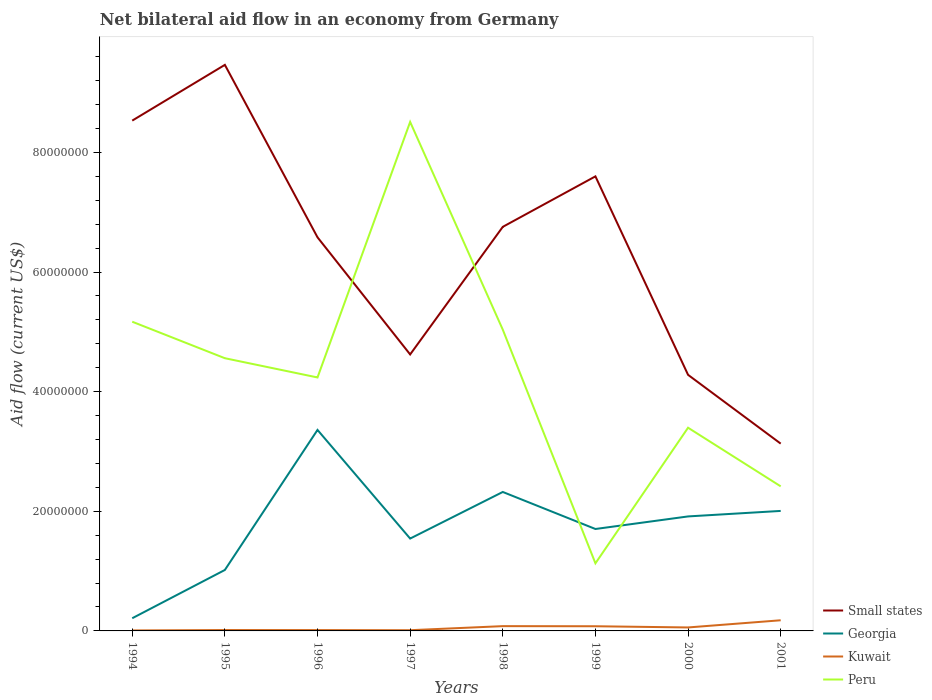Does the line corresponding to Peru intersect with the line corresponding to Kuwait?
Ensure brevity in your answer.  No. Is the number of lines equal to the number of legend labels?
Your response must be concise. Yes. Across all years, what is the maximum net bilateral aid flow in Kuwait?
Offer a terse response. 8.00e+04. In which year was the net bilateral aid flow in Small states maximum?
Ensure brevity in your answer.  2001. What is the total net bilateral aid flow in Georgia in the graph?
Make the answer very short. 3.17e+06. What is the difference between the highest and the second highest net bilateral aid flow in Georgia?
Your answer should be very brief. 3.15e+07. What is the difference between the highest and the lowest net bilateral aid flow in Georgia?
Offer a terse response. 4. Is the net bilateral aid flow in Georgia strictly greater than the net bilateral aid flow in Peru over the years?
Offer a terse response. No. Does the graph contain any zero values?
Offer a very short reply. No. Does the graph contain grids?
Ensure brevity in your answer.  No. Where does the legend appear in the graph?
Offer a very short reply. Bottom right. How many legend labels are there?
Give a very brief answer. 4. What is the title of the graph?
Your answer should be very brief. Net bilateral aid flow in an economy from Germany. What is the label or title of the Y-axis?
Give a very brief answer. Aid flow (current US$). What is the Aid flow (current US$) of Small states in 1994?
Provide a short and direct response. 8.53e+07. What is the Aid flow (current US$) in Georgia in 1994?
Make the answer very short. 2.12e+06. What is the Aid flow (current US$) in Peru in 1994?
Your answer should be very brief. 5.17e+07. What is the Aid flow (current US$) in Small states in 1995?
Make the answer very short. 9.46e+07. What is the Aid flow (current US$) in Georgia in 1995?
Keep it short and to the point. 1.02e+07. What is the Aid flow (current US$) of Peru in 1995?
Your answer should be very brief. 4.56e+07. What is the Aid flow (current US$) of Small states in 1996?
Offer a very short reply. 6.58e+07. What is the Aid flow (current US$) of Georgia in 1996?
Provide a succinct answer. 3.36e+07. What is the Aid flow (current US$) of Peru in 1996?
Offer a very short reply. 4.24e+07. What is the Aid flow (current US$) of Small states in 1997?
Offer a terse response. 4.62e+07. What is the Aid flow (current US$) in Georgia in 1997?
Ensure brevity in your answer.  1.54e+07. What is the Aid flow (current US$) in Peru in 1997?
Provide a succinct answer. 8.51e+07. What is the Aid flow (current US$) in Small states in 1998?
Provide a succinct answer. 6.76e+07. What is the Aid flow (current US$) of Georgia in 1998?
Your response must be concise. 2.32e+07. What is the Aid flow (current US$) of Peru in 1998?
Provide a succinct answer. 5.04e+07. What is the Aid flow (current US$) in Small states in 1999?
Ensure brevity in your answer.  7.60e+07. What is the Aid flow (current US$) of Georgia in 1999?
Offer a terse response. 1.70e+07. What is the Aid flow (current US$) of Kuwait in 1999?
Provide a succinct answer. 7.80e+05. What is the Aid flow (current US$) in Peru in 1999?
Your response must be concise. 1.13e+07. What is the Aid flow (current US$) of Small states in 2000?
Provide a succinct answer. 4.28e+07. What is the Aid flow (current US$) in Georgia in 2000?
Your response must be concise. 1.91e+07. What is the Aid flow (current US$) of Kuwait in 2000?
Your answer should be compact. 5.80e+05. What is the Aid flow (current US$) in Peru in 2000?
Provide a succinct answer. 3.40e+07. What is the Aid flow (current US$) of Small states in 2001?
Offer a very short reply. 3.13e+07. What is the Aid flow (current US$) in Georgia in 2001?
Offer a terse response. 2.01e+07. What is the Aid flow (current US$) of Kuwait in 2001?
Your response must be concise. 1.78e+06. What is the Aid flow (current US$) in Peru in 2001?
Make the answer very short. 2.42e+07. Across all years, what is the maximum Aid flow (current US$) in Small states?
Offer a very short reply. 9.46e+07. Across all years, what is the maximum Aid flow (current US$) of Georgia?
Offer a terse response. 3.36e+07. Across all years, what is the maximum Aid flow (current US$) in Kuwait?
Provide a short and direct response. 1.78e+06. Across all years, what is the maximum Aid flow (current US$) in Peru?
Your answer should be compact. 8.51e+07. Across all years, what is the minimum Aid flow (current US$) of Small states?
Ensure brevity in your answer.  3.13e+07. Across all years, what is the minimum Aid flow (current US$) in Georgia?
Give a very brief answer. 2.12e+06. Across all years, what is the minimum Aid flow (current US$) in Peru?
Your answer should be very brief. 1.13e+07. What is the total Aid flow (current US$) in Small states in the graph?
Make the answer very short. 5.10e+08. What is the total Aid flow (current US$) of Georgia in the graph?
Ensure brevity in your answer.  1.41e+08. What is the total Aid flow (current US$) in Kuwait in the graph?
Your answer should be compact. 4.43e+06. What is the total Aid flow (current US$) in Peru in the graph?
Your answer should be compact. 3.45e+08. What is the difference between the Aid flow (current US$) of Small states in 1994 and that in 1995?
Offer a terse response. -9.32e+06. What is the difference between the Aid flow (current US$) of Georgia in 1994 and that in 1995?
Give a very brief answer. -8.07e+06. What is the difference between the Aid flow (current US$) in Kuwait in 1994 and that in 1995?
Keep it short and to the point. -7.00e+04. What is the difference between the Aid flow (current US$) in Peru in 1994 and that in 1995?
Give a very brief answer. 6.10e+06. What is the difference between the Aid flow (current US$) in Small states in 1994 and that in 1996?
Offer a very short reply. 1.95e+07. What is the difference between the Aid flow (current US$) in Georgia in 1994 and that in 1996?
Provide a short and direct response. -3.15e+07. What is the difference between the Aid flow (current US$) in Peru in 1994 and that in 1996?
Provide a short and direct response. 9.32e+06. What is the difference between the Aid flow (current US$) of Small states in 1994 and that in 1997?
Offer a terse response. 3.91e+07. What is the difference between the Aid flow (current US$) of Georgia in 1994 and that in 1997?
Your response must be concise. -1.33e+07. What is the difference between the Aid flow (current US$) of Kuwait in 1994 and that in 1997?
Make the answer very short. -4.00e+04. What is the difference between the Aid flow (current US$) of Peru in 1994 and that in 1997?
Offer a terse response. -3.34e+07. What is the difference between the Aid flow (current US$) of Small states in 1994 and that in 1998?
Make the answer very short. 1.78e+07. What is the difference between the Aid flow (current US$) of Georgia in 1994 and that in 1998?
Your answer should be compact. -2.11e+07. What is the difference between the Aid flow (current US$) in Kuwait in 1994 and that in 1998?
Offer a very short reply. -7.20e+05. What is the difference between the Aid flow (current US$) of Peru in 1994 and that in 1998?
Offer a terse response. 1.33e+06. What is the difference between the Aid flow (current US$) in Small states in 1994 and that in 1999?
Your answer should be very brief. 9.32e+06. What is the difference between the Aid flow (current US$) in Georgia in 1994 and that in 1999?
Your response must be concise. -1.49e+07. What is the difference between the Aid flow (current US$) of Kuwait in 1994 and that in 1999?
Offer a terse response. -7.00e+05. What is the difference between the Aid flow (current US$) in Peru in 1994 and that in 1999?
Offer a terse response. 4.04e+07. What is the difference between the Aid flow (current US$) in Small states in 1994 and that in 2000?
Keep it short and to the point. 4.25e+07. What is the difference between the Aid flow (current US$) of Georgia in 1994 and that in 2000?
Offer a terse response. -1.70e+07. What is the difference between the Aid flow (current US$) in Kuwait in 1994 and that in 2000?
Make the answer very short. -5.00e+05. What is the difference between the Aid flow (current US$) of Peru in 1994 and that in 2000?
Provide a short and direct response. 1.77e+07. What is the difference between the Aid flow (current US$) of Small states in 1994 and that in 2001?
Provide a short and direct response. 5.40e+07. What is the difference between the Aid flow (current US$) of Georgia in 1994 and that in 2001?
Give a very brief answer. -1.79e+07. What is the difference between the Aid flow (current US$) of Kuwait in 1994 and that in 2001?
Ensure brevity in your answer.  -1.70e+06. What is the difference between the Aid flow (current US$) of Peru in 1994 and that in 2001?
Give a very brief answer. 2.75e+07. What is the difference between the Aid flow (current US$) in Small states in 1995 and that in 1996?
Offer a terse response. 2.88e+07. What is the difference between the Aid flow (current US$) in Georgia in 1995 and that in 1996?
Offer a very short reply. -2.34e+07. What is the difference between the Aid flow (current US$) of Kuwait in 1995 and that in 1996?
Make the answer very short. 10000. What is the difference between the Aid flow (current US$) in Peru in 1995 and that in 1996?
Your answer should be compact. 3.22e+06. What is the difference between the Aid flow (current US$) of Small states in 1995 and that in 1997?
Keep it short and to the point. 4.84e+07. What is the difference between the Aid flow (current US$) in Georgia in 1995 and that in 1997?
Your answer should be very brief. -5.25e+06. What is the difference between the Aid flow (current US$) in Peru in 1995 and that in 1997?
Offer a very short reply. -3.95e+07. What is the difference between the Aid flow (current US$) in Small states in 1995 and that in 1998?
Make the answer very short. 2.71e+07. What is the difference between the Aid flow (current US$) of Georgia in 1995 and that in 1998?
Provide a short and direct response. -1.30e+07. What is the difference between the Aid flow (current US$) of Kuwait in 1995 and that in 1998?
Offer a very short reply. -6.50e+05. What is the difference between the Aid flow (current US$) in Peru in 1995 and that in 1998?
Your response must be concise. -4.77e+06. What is the difference between the Aid flow (current US$) of Small states in 1995 and that in 1999?
Make the answer very short. 1.86e+07. What is the difference between the Aid flow (current US$) in Georgia in 1995 and that in 1999?
Provide a short and direct response. -6.85e+06. What is the difference between the Aid flow (current US$) in Kuwait in 1995 and that in 1999?
Offer a terse response. -6.30e+05. What is the difference between the Aid flow (current US$) in Peru in 1995 and that in 1999?
Your response must be concise. 3.43e+07. What is the difference between the Aid flow (current US$) of Small states in 1995 and that in 2000?
Give a very brief answer. 5.18e+07. What is the difference between the Aid flow (current US$) of Georgia in 1995 and that in 2000?
Keep it short and to the point. -8.95e+06. What is the difference between the Aid flow (current US$) of Kuwait in 1995 and that in 2000?
Give a very brief answer. -4.30e+05. What is the difference between the Aid flow (current US$) in Peru in 1995 and that in 2000?
Your response must be concise. 1.16e+07. What is the difference between the Aid flow (current US$) of Small states in 1995 and that in 2001?
Give a very brief answer. 6.33e+07. What is the difference between the Aid flow (current US$) of Georgia in 1995 and that in 2001?
Your answer should be compact. -9.87e+06. What is the difference between the Aid flow (current US$) in Kuwait in 1995 and that in 2001?
Offer a very short reply. -1.63e+06. What is the difference between the Aid flow (current US$) of Peru in 1995 and that in 2001?
Give a very brief answer. 2.14e+07. What is the difference between the Aid flow (current US$) of Small states in 1996 and that in 1997?
Keep it short and to the point. 1.96e+07. What is the difference between the Aid flow (current US$) in Georgia in 1996 and that in 1997?
Make the answer very short. 1.82e+07. What is the difference between the Aid flow (current US$) of Kuwait in 1996 and that in 1997?
Offer a very short reply. 2.00e+04. What is the difference between the Aid flow (current US$) of Peru in 1996 and that in 1997?
Make the answer very short. -4.27e+07. What is the difference between the Aid flow (current US$) of Small states in 1996 and that in 1998?
Give a very brief answer. -1.75e+06. What is the difference between the Aid flow (current US$) of Georgia in 1996 and that in 1998?
Provide a short and direct response. 1.04e+07. What is the difference between the Aid flow (current US$) in Kuwait in 1996 and that in 1998?
Your answer should be very brief. -6.60e+05. What is the difference between the Aid flow (current US$) of Peru in 1996 and that in 1998?
Ensure brevity in your answer.  -7.99e+06. What is the difference between the Aid flow (current US$) in Small states in 1996 and that in 1999?
Provide a short and direct response. -1.02e+07. What is the difference between the Aid flow (current US$) of Georgia in 1996 and that in 1999?
Your answer should be very brief. 1.66e+07. What is the difference between the Aid flow (current US$) in Kuwait in 1996 and that in 1999?
Your answer should be compact. -6.40e+05. What is the difference between the Aid flow (current US$) of Peru in 1996 and that in 1999?
Your answer should be very brief. 3.11e+07. What is the difference between the Aid flow (current US$) of Small states in 1996 and that in 2000?
Offer a terse response. 2.30e+07. What is the difference between the Aid flow (current US$) of Georgia in 1996 and that in 2000?
Provide a short and direct response. 1.45e+07. What is the difference between the Aid flow (current US$) of Kuwait in 1996 and that in 2000?
Keep it short and to the point. -4.40e+05. What is the difference between the Aid flow (current US$) in Peru in 1996 and that in 2000?
Offer a terse response. 8.40e+06. What is the difference between the Aid flow (current US$) of Small states in 1996 and that in 2001?
Provide a short and direct response. 3.45e+07. What is the difference between the Aid flow (current US$) in Georgia in 1996 and that in 2001?
Give a very brief answer. 1.35e+07. What is the difference between the Aid flow (current US$) of Kuwait in 1996 and that in 2001?
Make the answer very short. -1.64e+06. What is the difference between the Aid flow (current US$) of Peru in 1996 and that in 2001?
Provide a short and direct response. 1.82e+07. What is the difference between the Aid flow (current US$) in Small states in 1997 and that in 1998?
Make the answer very short. -2.13e+07. What is the difference between the Aid flow (current US$) of Georgia in 1997 and that in 1998?
Keep it short and to the point. -7.79e+06. What is the difference between the Aid flow (current US$) of Kuwait in 1997 and that in 1998?
Your answer should be very brief. -6.80e+05. What is the difference between the Aid flow (current US$) of Peru in 1997 and that in 1998?
Make the answer very short. 3.47e+07. What is the difference between the Aid flow (current US$) in Small states in 1997 and that in 1999?
Ensure brevity in your answer.  -2.98e+07. What is the difference between the Aid flow (current US$) in Georgia in 1997 and that in 1999?
Offer a very short reply. -1.60e+06. What is the difference between the Aid flow (current US$) in Kuwait in 1997 and that in 1999?
Your response must be concise. -6.60e+05. What is the difference between the Aid flow (current US$) in Peru in 1997 and that in 1999?
Your response must be concise. 7.38e+07. What is the difference between the Aid flow (current US$) of Small states in 1997 and that in 2000?
Your answer should be compact. 3.41e+06. What is the difference between the Aid flow (current US$) in Georgia in 1997 and that in 2000?
Your answer should be very brief. -3.70e+06. What is the difference between the Aid flow (current US$) of Kuwait in 1997 and that in 2000?
Your answer should be very brief. -4.60e+05. What is the difference between the Aid flow (current US$) of Peru in 1997 and that in 2000?
Keep it short and to the point. 5.11e+07. What is the difference between the Aid flow (current US$) of Small states in 1997 and that in 2001?
Ensure brevity in your answer.  1.49e+07. What is the difference between the Aid flow (current US$) of Georgia in 1997 and that in 2001?
Keep it short and to the point. -4.62e+06. What is the difference between the Aid flow (current US$) in Kuwait in 1997 and that in 2001?
Give a very brief answer. -1.66e+06. What is the difference between the Aid flow (current US$) in Peru in 1997 and that in 2001?
Make the answer very short. 6.09e+07. What is the difference between the Aid flow (current US$) in Small states in 1998 and that in 1999?
Your answer should be compact. -8.44e+06. What is the difference between the Aid flow (current US$) in Georgia in 1998 and that in 1999?
Provide a short and direct response. 6.19e+06. What is the difference between the Aid flow (current US$) in Peru in 1998 and that in 1999?
Offer a very short reply. 3.91e+07. What is the difference between the Aid flow (current US$) in Small states in 1998 and that in 2000?
Give a very brief answer. 2.47e+07. What is the difference between the Aid flow (current US$) in Georgia in 1998 and that in 2000?
Offer a very short reply. 4.09e+06. What is the difference between the Aid flow (current US$) in Kuwait in 1998 and that in 2000?
Ensure brevity in your answer.  2.20e+05. What is the difference between the Aid flow (current US$) of Peru in 1998 and that in 2000?
Keep it short and to the point. 1.64e+07. What is the difference between the Aid flow (current US$) of Small states in 1998 and that in 2001?
Offer a terse response. 3.62e+07. What is the difference between the Aid flow (current US$) in Georgia in 1998 and that in 2001?
Provide a short and direct response. 3.17e+06. What is the difference between the Aid flow (current US$) in Kuwait in 1998 and that in 2001?
Provide a succinct answer. -9.80e+05. What is the difference between the Aid flow (current US$) of Peru in 1998 and that in 2001?
Your answer should be very brief. 2.62e+07. What is the difference between the Aid flow (current US$) of Small states in 1999 and that in 2000?
Ensure brevity in your answer.  3.32e+07. What is the difference between the Aid flow (current US$) of Georgia in 1999 and that in 2000?
Give a very brief answer. -2.10e+06. What is the difference between the Aid flow (current US$) of Peru in 1999 and that in 2000?
Make the answer very short. -2.27e+07. What is the difference between the Aid flow (current US$) of Small states in 1999 and that in 2001?
Your response must be concise. 4.47e+07. What is the difference between the Aid flow (current US$) in Georgia in 1999 and that in 2001?
Offer a very short reply. -3.02e+06. What is the difference between the Aid flow (current US$) in Kuwait in 1999 and that in 2001?
Provide a succinct answer. -1.00e+06. What is the difference between the Aid flow (current US$) of Peru in 1999 and that in 2001?
Keep it short and to the point. -1.29e+07. What is the difference between the Aid flow (current US$) in Small states in 2000 and that in 2001?
Keep it short and to the point. 1.15e+07. What is the difference between the Aid flow (current US$) in Georgia in 2000 and that in 2001?
Make the answer very short. -9.20e+05. What is the difference between the Aid flow (current US$) of Kuwait in 2000 and that in 2001?
Your answer should be very brief. -1.20e+06. What is the difference between the Aid flow (current US$) in Peru in 2000 and that in 2001?
Your answer should be very brief. 9.80e+06. What is the difference between the Aid flow (current US$) in Small states in 1994 and the Aid flow (current US$) in Georgia in 1995?
Your answer should be very brief. 7.51e+07. What is the difference between the Aid flow (current US$) in Small states in 1994 and the Aid flow (current US$) in Kuwait in 1995?
Your response must be concise. 8.52e+07. What is the difference between the Aid flow (current US$) of Small states in 1994 and the Aid flow (current US$) of Peru in 1995?
Provide a short and direct response. 3.97e+07. What is the difference between the Aid flow (current US$) of Georgia in 1994 and the Aid flow (current US$) of Kuwait in 1995?
Offer a terse response. 1.97e+06. What is the difference between the Aid flow (current US$) of Georgia in 1994 and the Aid flow (current US$) of Peru in 1995?
Give a very brief answer. -4.35e+07. What is the difference between the Aid flow (current US$) in Kuwait in 1994 and the Aid flow (current US$) in Peru in 1995?
Your answer should be compact. -4.55e+07. What is the difference between the Aid flow (current US$) in Small states in 1994 and the Aid flow (current US$) in Georgia in 1996?
Provide a succinct answer. 5.17e+07. What is the difference between the Aid flow (current US$) of Small states in 1994 and the Aid flow (current US$) of Kuwait in 1996?
Make the answer very short. 8.52e+07. What is the difference between the Aid flow (current US$) in Small states in 1994 and the Aid flow (current US$) in Peru in 1996?
Ensure brevity in your answer.  4.29e+07. What is the difference between the Aid flow (current US$) of Georgia in 1994 and the Aid flow (current US$) of Kuwait in 1996?
Offer a terse response. 1.98e+06. What is the difference between the Aid flow (current US$) in Georgia in 1994 and the Aid flow (current US$) in Peru in 1996?
Provide a short and direct response. -4.02e+07. What is the difference between the Aid flow (current US$) of Kuwait in 1994 and the Aid flow (current US$) of Peru in 1996?
Your answer should be very brief. -4.23e+07. What is the difference between the Aid flow (current US$) of Small states in 1994 and the Aid flow (current US$) of Georgia in 1997?
Offer a very short reply. 6.99e+07. What is the difference between the Aid flow (current US$) in Small states in 1994 and the Aid flow (current US$) in Kuwait in 1997?
Offer a very short reply. 8.52e+07. What is the difference between the Aid flow (current US$) of Georgia in 1994 and the Aid flow (current US$) of Peru in 1997?
Your answer should be compact. -8.30e+07. What is the difference between the Aid flow (current US$) in Kuwait in 1994 and the Aid flow (current US$) in Peru in 1997?
Keep it short and to the point. -8.50e+07. What is the difference between the Aid flow (current US$) of Small states in 1994 and the Aid flow (current US$) of Georgia in 1998?
Your answer should be very brief. 6.21e+07. What is the difference between the Aid flow (current US$) of Small states in 1994 and the Aid flow (current US$) of Kuwait in 1998?
Offer a terse response. 8.45e+07. What is the difference between the Aid flow (current US$) of Small states in 1994 and the Aid flow (current US$) of Peru in 1998?
Your response must be concise. 3.50e+07. What is the difference between the Aid flow (current US$) in Georgia in 1994 and the Aid flow (current US$) in Kuwait in 1998?
Your response must be concise. 1.32e+06. What is the difference between the Aid flow (current US$) in Georgia in 1994 and the Aid flow (current US$) in Peru in 1998?
Your answer should be very brief. -4.82e+07. What is the difference between the Aid flow (current US$) in Kuwait in 1994 and the Aid flow (current US$) in Peru in 1998?
Offer a terse response. -5.03e+07. What is the difference between the Aid flow (current US$) of Small states in 1994 and the Aid flow (current US$) of Georgia in 1999?
Make the answer very short. 6.83e+07. What is the difference between the Aid flow (current US$) of Small states in 1994 and the Aid flow (current US$) of Kuwait in 1999?
Your answer should be compact. 8.45e+07. What is the difference between the Aid flow (current US$) in Small states in 1994 and the Aid flow (current US$) in Peru in 1999?
Make the answer very short. 7.40e+07. What is the difference between the Aid flow (current US$) of Georgia in 1994 and the Aid flow (current US$) of Kuwait in 1999?
Make the answer very short. 1.34e+06. What is the difference between the Aid flow (current US$) of Georgia in 1994 and the Aid flow (current US$) of Peru in 1999?
Keep it short and to the point. -9.18e+06. What is the difference between the Aid flow (current US$) of Kuwait in 1994 and the Aid flow (current US$) of Peru in 1999?
Your answer should be compact. -1.12e+07. What is the difference between the Aid flow (current US$) of Small states in 1994 and the Aid flow (current US$) of Georgia in 2000?
Offer a very short reply. 6.62e+07. What is the difference between the Aid flow (current US$) of Small states in 1994 and the Aid flow (current US$) of Kuwait in 2000?
Give a very brief answer. 8.47e+07. What is the difference between the Aid flow (current US$) in Small states in 1994 and the Aid flow (current US$) in Peru in 2000?
Keep it short and to the point. 5.13e+07. What is the difference between the Aid flow (current US$) of Georgia in 1994 and the Aid flow (current US$) of Kuwait in 2000?
Keep it short and to the point. 1.54e+06. What is the difference between the Aid flow (current US$) of Georgia in 1994 and the Aid flow (current US$) of Peru in 2000?
Provide a succinct answer. -3.18e+07. What is the difference between the Aid flow (current US$) of Kuwait in 1994 and the Aid flow (current US$) of Peru in 2000?
Your response must be concise. -3.39e+07. What is the difference between the Aid flow (current US$) in Small states in 1994 and the Aid flow (current US$) in Georgia in 2001?
Ensure brevity in your answer.  6.52e+07. What is the difference between the Aid flow (current US$) of Small states in 1994 and the Aid flow (current US$) of Kuwait in 2001?
Keep it short and to the point. 8.35e+07. What is the difference between the Aid flow (current US$) of Small states in 1994 and the Aid flow (current US$) of Peru in 2001?
Your answer should be compact. 6.11e+07. What is the difference between the Aid flow (current US$) in Georgia in 1994 and the Aid flow (current US$) in Peru in 2001?
Offer a very short reply. -2.20e+07. What is the difference between the Aid flow (current US$) in Kuwait in 1994 and the Aid flow (current US$) in Peru in 2001?
Your answer should be compact. -2.41e+07. What is the difference between the Aid flow (current US$) of Small states in 1995 and the Aid flow (current US$) of Georgia in 1996?
Keep it short and to the point. 6.10e+07. What is the difference between the Aid flow (current US$) of Small states in 1995 and the Aid flow (current US$) of Kuwait in 1996?
Provide a succinct answer. 9.45e+07. What is the difference between the Aid flow (current US$) in Small states in 1995 and the Aid flow (current US$) in Peru in 1996?
Offer a very short reply. 5.23e+07. What is the difference between the Aid flow (current US$) of Georgia in 1995 and the Aid flow (current US$) of Kuwait in 1996?
Offer a very short reply. 1.00e+07. What is the difference between the Aid flow (current US$) in Georgia in 1995 and the Aid flow (current US$) in Peru in 1996?
Ensure brevity in your answer.  -3.22e+07. What is the difference between the Aid flow (current US$) of Kuwait in 1995 and the Aid flow (current US$) of Peru in 1996?
Keep it short and to the point. -4.22e+07. What is the difference between the Aid flow (current US$) of Small states in 1995 and the Aid flow (current US$) of Georgia in 1997?
Offer a very short reply. 7.92e+07. What is the difference between the Aid flow (current US$) in Small states in 1995 and the Aid flow (current US$) in Kuwait in 1997?
Give a very brief answer. 9.45e+07. What is the difference between the Aid flow (current US$) of Small states in 1995 and the Aid flow (current US$) of Peru in 1997?
Your answer should be compact. 9.54e+06. What is the difference between the Aid flow (current US$) of Georgia in 1995 and the Aid flow (current US$) of Kuwait in 1997?
Keep it short and to the point. 1.01e+07. What is the difference between the Aid flow (current US$) in Georgia in 1995 and the Aid flow (current US$) in Peru in 1997?
Offer a terse response. -7.49e+07. What is the difference between the Aid flow (current US$) in Kuwait in 1995 and the Aid flow (current US$) in Peru in 1997?
Your answer should be compact. -8.49e+07. What is the difference between the Aid flow (current US$) in Small states in 1995 and the Aid flow (current US$) in Georgia in 1998?
Keep it short and to the point. 7.14e+07. What is the difference between the Aid flow (current US$) of Small states in 1995 and the Aid flow (current US$) of Kuwait in 1998?
Make the answer very short. 9.38e+07. What is the difference between the Aid flow (current US$) in Small states in 1995 and the Aid flow (current US$) in Peru in 1998?
Your response must be concise. 4.43e+07. What is the difference between the Aid flow (current US$) of Georgia in 1995 and the Aid flow (current US$) of Kuwait in 1998?
Ensure brevity in your answer.  9.39e+06. What is the difference between the Aid flow (current US$) of Georgia in 1995 and the Aid flow (current US$) of Peru in 1998?
Provide a succinct answer. -4.02e+07. What is the difference between the Aid flow (current US$) in Kuwait in 1995 and the Aid flow (current US$) in Peru in 1998?
Give a very brief answer. -5.02e+07. What is the difference between the Aid flow (current US$) in Small states in 1995 and the Aid flow (current US$) in Georgia in 1999?
Offer a very short reply. 7.76e+07. What is the difference between the Aid flow (current US$) of Small states in 1995 and the Aid flow (current US$) of Kuwait in 1999?
Make the answer very short. 9.38e+07. What is the difference between the Aid flow (current US$) in Small states in 1995 and the Aid flow (current US$) in Peru in 1999?
Provide a succinct answer. 8.33e+07. What is the difference between the Aid flow (current US$) in Georgia in 1995 and the Aid flow (current US$) in Kuwait in 1999?
Your response must be concise. 9.41e+06. What is the difference between the Aid flow (current US$) of Georgia in 1995 and the Aid flow (current US$) of Peru in 1999?
Make the answer very short. -1.11e+06. What is the difference between the Aid flow (current US$) of Kuwait in 1995 and the Aid flow (current US$) of Peru in 1999?
Make the answer very short. -1.12e+07. What is the difference between the Aid flow (current US$) of Small states in 1995 and the Aid flow (current US$) of Georgia in 2000?
Your answer should be compact. 7.55e+07. What is the difference between the Aid flow (current US$) in Small states in 1995 and the Aid flow (current US$) in Kuwait in 2000?
Your response must be concise. 9.40e+07. What is the difference between the Aid flow (current US$) in Small states in 1995 and the Aid flow (current US$) in Peru in 2000?
Your response must be concise. 6.07e+07. What is the difference between the Aid flow (current US$) of Georgia in 1995 and the Aid flow (current US$) of Kuwait in 2000?
Ensure brevity in your answer.  9.61e+06. What is the difference between the Aid flow (current US$) of Georgia in 1995 and the Aid flow (current US$) of Peru in 2000?
Ensure brevity in your answer.  -2.38e+07. What is the difference between the Aid flow (current US$) of Kuwait in 1995 and the Aid flow (current US$) of Peru in 2000?
Offer a terse response. -3.38e+07. What is the difference between the Aid flow (current US$) of Small states in 1995 and the Aid flow (current US$) of Georgia in 2001?
Ensure brevity in your answer.  7.46e+07. What is the difference between the Aid flow (current US$) of Small states in 1995 and the Aid flow (current US$) of Kuwait in 2001?
Offer a terse response. 9.28e+07. What is the difference between the Aid flow (current US$) in Small states in 1995 and the Aid flow (current US$) in Peru in 2001?
Keep it short and to the point. 7.05e+07. What is the difference between the Aid flow (current US$) of Georgia in 1995 and the Aid flow (current US$) of Kuwait in 2001?
Make the answer very short. 8.41e+06. What is the difference between the Aid flow (current US$) of Georgia in 1995 and the Aid flow (current US$) of Peru in 2001?
Provide a short and direct response. -1.40e+07. What is the difference between the Aid flow (current US$) of Kuwait in 1995 and the Aid flow (current US$) of Peru in 2001?
Your answer should be very brief. -2.40e+07. What is the difference between the Aid flow (current US$) in Small states in 1996 and the Aid flow (current US$) in Georgia in 1997?
Keep it short and to the point. 5.04e+07. What is the difference between the Aid flow (current US$) of Small states in 1996 and the Aid flow (current US$) of Kuwait in 1997?
Provide a short and direct response. 6.57e+07. What is the difference between the Aid flow (current US$) in Small states in 1996 and the Aid flow (current US$) in Peru in 1997?
Ensure brevity in your answer.  -1.93e+07. What is the difference between the Aid flow (current US$) in Georgia in 1996 and the Aid flow (current US$) in Kuwait in 1997?
Make the answer very short. 3.35e+07. What is the difference between the Aid flow (current US$) in Georgia in 1996 and the Aid flow (current US$) in Peru in 1997?
Provide a short and direct response. -5.15e+07. What is the difference between the Aid flow (current US$) of Kuwait in 1996 and the Aid flow (current US$) of Peru in 1997?
Your answer should be very brief. -8.50e+07. What is the difference between the Aid flow (current US$) in Small states in 1996 and the Aid flow (current US$) in Georgia in 1998?
Provide a succinct answer. 4.26e+07. What is the difference between the Aid flow (current US$) of Small states in 1996 and the Aid flow (current US$) of Kuwait in 1998?
Provide a succinct answer. 6.50e+07. What is the difference between the Aid flow (current US$) of Small states in 1996 and the Aid flow (current US$) of Peru in 1998?
Offer a very short reply. 1.54e+07. What is the difference between the Aid flow (current US$) of Georgia in 1996 and the Aid flow (current US$) of Kuwait in 1998?
Provide a short and direct response. 3.28e+07. What is the difference between the Aid flow (current US$) of Georgia in 1996 and the Aid flow (current US$) of Peru in 1998?
Provide a succinct answer. -1.68e+07. What is the difference between the Aid flow (current US$) of Kuwait in 1996 and the Aid flow (current US$) of Peru in 1998?
Ensure brevity in your answer.  -5.02e+07. What is the difference between the Aid flow (current US$) of Small states in 1996 and the Aid flow (current US$) of Georgia in 1999?
Offer a terse response. 4.88e+07. What is the difference between the Aid flow (current US$) in Small states in 1996 and the Aid flow (current US$) in Kuwait in 1999?
Ensure brevity in your answer.  6.50e+07. What is the difference between the Aid flow (current US$) in Small states in 1996 and the Aid flow (current US$) in Peru in 1999?
Offer a very short reply. 5.45e+07. What is the difference between the Aid flow (current US$) of Georgia in 1996 and the Aid flow (current US$) of Kuwait in 1999?
Your answer should be compact. 3.28e+07. What is the difference between the Aid flow (current US$) in Georgia in 1996 and the Aid flow (current US$) in Peru in 1999?
Make the answer very short. 2.23e+07. What is the difference between the Aid flow (current US$) of Kuwait in 1996 and the Aid flow (current US$) of Peru in 1999?
Provide a succinct answer. -1.12e+07. What is the difference between the Aid flow (current US$) in Small states in 1996 and the Aid flow (current US$) in Georgia in 2000?
Provide a succinct answer. 4.67e+07. What is the difference between the Aid flow (current US$) in Small states in 1996 and the Aid flow (current US$) in Kuwait in 2000?
Provide a succinct answer. 6.52e+07. What is the difference between the Aid flow (current US$) in Small states in 1996 and the Aid flow (current US$) in Peru in 2000?
Your answer should be very brief. 3.18e+07. What is the difference between the Aid flow (current US$) in Georgia in 1996 and the Aid flow (current US$) in Kuwait in 2000?
Your answer should be compact. 3.30e+07. What is the difference between the Aid flow (current US$) of Georgia in 1996 and the Aid flow (current US$) of Peru in 2000?
Give a very brief answer. -3.70e+05. What is the difference between the Aid flow (current US$) of Kuwait in 1996 and the Aid flow (current US$) of Peru in 2000?
Make the answer very short. -3.38e+07. What is the difference between the Aid flow (current US$) of Small states in 1996 and the Aid flow (current US$) of Georgia in 2001?
Your answer should be compact. 4.57e+07. What is the difference between the Aid flow (current US$) of Small states in 1996 and the Aid flow (current US$) of Kuwait in 2001?
Offer a terse response. 6.40e+07. What is the difference between the Aid flow (current US$) of Small states in 1996 and the Aid flow (current US$) of Peru in 2001?
Make the answer very short. 4.16e+07. What is the difference between the Aid flow (current US$) in Georgia in 1996 and the Aid flow (current US$) in Kuwait in 2001?
Keep it short and to the point. 3.18e+07. What is the difference between the Aid flow (current US$) in Georgia in 1996 and the Aid flow (current US$) in Peru in 2001?
Give a very brief answer. 9.43e+06. What is the difference between the Aid flow (current US$) of Kuwait in 1996 and the Aid flow (current US$) of Peru in 2001?
Provide a short and direct response. -2.40e+07. What is the difference between the Aid flow (current US$) of Small states in 1997 and the Aid flow (current US$) of Georgia in 1998?
Ensure brevity in your answer.  2.30e+07. What is the difference between the Aid flow (current US$) in Small states in 1997 and the Aid flow (current US$) in Kuwait in 1998?
Your answer should be very brief. 4.54e+07. What is the difference between the Aid flow (current US$) in Small states in 1997 and the Aid flow (current US$) in Peru in 1998?
Ensure brevity in your answer.  -4.14e+06. What is the difference between the Aid flow (current US$) of Georgia in 1997 and the Aid flow (current US$) of Kuwait in 1998?
Your answer should be very brief. 1.46e+07. What is the difference between the Aid flow (current US$) in Georgia in 1997 and the Aid flow (current US$) in Peru in 1998?
Make the answer very short. -3.49e+07. What is the difference between the Aid flow (current US$) of Kuwait in 1997 and the Aid flow (current US$) of Peru in 1998?
Offer a terse response. -5.02e+07. What is the difference between the Aid flow (current US$) of Small states in 1997 and the Aid flow (current US$) of Georgia in 1999?
Offer a very short reply. 2.92e+07. What is the difference between the Aid flow (current US$) in Small states in 1997 and the Aid flow (current US$) in Kuwait in 1999?
Your answer should be very brief. 4.54e+07. What is the difference between the Aid flow (current US$) in Small states in 1997 and the Aid flow (current US$) in Peru in 1999?
Your answer should be compact. 3.49e+07. What is the difference between the Aid flow (current US$) of Georgia in 1997 and the Aid flow (current US$) of Kuwait in 1999?
Make the answer very short. 1.47e+07. What is the difference between the Aid flow (current US$) of Georgia in 1997 and the Aid flow (current US$) of Peru in 1999?
Your answer should be very brief. 4.14e+06. What is the difference between the Aid flow (current US$) of Kuwait in 1997 and the Aid flow (current US$) of Peru in 1999?
Offer a very short reply. -1.12e+07. What is the difference between the Aid flow (current US$) of Small states in 1997 and the Aid flow (current US$) of Georgia in 2000?
Make the answer very short. 2.71e+07. What is the difference between the Aid flow (current US$) in Small states in 1997 and the Aid flow (current US$) in Kuwait in 2000?
Offer a terse response. 4.56e+07. What is the difference between the Aid flow (current US$) of Small states in 1997 and the Aid flow (current US$) of Peru in 2000?
Ensure brevity in your answer.  1.22e+07. What is the difference between the Aid flow (current US$) in Georgia in 1997 and the Aid flow (current US$) in Kuwait in 2000?
Provide a short and direct response. 1.49e+07. What is the difference between the Aid flow (current US$) in Georgia in 1997 and the Aid flow (current US$) in Peru in 2000?
Provide a short and direct response. -1.85e+07. What is the difference between the Aid flow (current US$) of Kuwait in 1997 and the Aid flow (current US$) of Peru in 2000?
Provide a short and direct response. -3.38e+07. What is the difference between the Aid flow (current US$) in Small states in 1997 and the Aid flow (current US$) in Georgia in 2001?
Make the answer very short. 2.62e+07. What is the difference between the Aid flow (current US$) in Small states in 1997 and the Aid flow (current US$) in Kuwait in 2001?
Provide a short and direct response. 4.44e+07. What is the difference between the Aid flow (current US$) in Small states in 1997 and the Aid flow (current US$) in Peru in 2001?
Offer a terse response. 2.20e+07. What is the difference between the Aid flow (current US$) in Georgia in 1997 and the Aid flow (current US$) in Kuwait in 2001?
Your response must be concise. 1.37e+07. What is the difference between the Aid flow (current US$) in Georgia in 1997 and the Aid flow (current US$) in Peru in 2001?
Your response must be concise. -8.73e+06. What is the difference between the Aid flow (current US$) in Kuwait in 1997 and the Aid flow (current US$) in Peru in 2001?
Your response must be concise. -2.40e+07. What is the difference between the Aid flow (current US$) of Small states in 1998 and the Aid flow (current US$) of Georgia in 1999?
Give a very brief answer. 5.05e+07. What is the difference between the Aid flow (current US$) of Small states in 1998 and the Aid flow (current US$) of Kuwait in 1999?
Give a very brief answer. 6.68e+07. What is the difference between the Aid flow (current US$) of Small states in 1998 and the Aid flow (current US$) of Peru in 1999?
Offer a very short reply. 5.62e+07. What is the difference between the Aid flow (current US$) of Georgia in 1998 and the Aid flow (current US$) of Kuwait in 1999?
Your response must be concise. 2.24e+07. What is the difference between the Aid flow (current US$) in Georgia in 1998 and the Aid flow (current US$) in Peru in 1999?
Provide a short and direct response. 1.19e+07. What is the difference between the Aid flow (current US$) of Kuwait in 1998 and the Aid flow (current US$) of Peru in 1999?
Your answer should be compact. -1.05e+07. What is the difference between the Aid flow (current US$) of Small states in 1998 and the Aid flow (current US$) of Georgia in 2000?
Ensure brevity in your answer.  4.84e+07. What is the difference between the Aid flow (current US$) in Small states in 1998 and the Aid flow (current US$) in Kuwait in 2000?
Provide a succinct answer. 6.70e+07. What is the difference between the Aid flow (current US$) of Small states in 1998 and the Aid flow (current US$) of Peru in 2000?
Provide a short and direct response. 3.36e+07. What is the difference between the Aid flow (current US$) of Georgia in 1998 and the Aid flow (current US$) of Kuwait in 2000?
Your answer should be very brief. 2.26e+07. What is the difference between the Aid flow (current US$) in Georgia in 1998 and the Aid flow (current US$) in Peru in 2000?
Provide a short and direct response. -1.07e+07. What is the difference between the Aid flow (current US$) of Kuwait in 1998 and the Aid flow (current US$) of Peru in 2000?
Provide a short and direct response. -3.32e+07. What is the difference between the Aid flow (current US$) of Small states in 1998 and the Aid flow (current US$) of Georgia in 2001?
Your answer should be very brief. 4.75e+07. What is the difference between the Aid flow (current US$) in Small states in 1998 and the Aid flow (current US$) in Kuwait in 2001?
Offer a very short reply. 6.58e+07. What is the difference between the Aid flow (current US$) of Small states in 1998 and the Aid flow (current US$) of Peru in 2001?
Your answer should be compact. 4.34e+07. What is the difference between the Aid flow (current US$) in Georgia in 1998 and the Aid flow (current US$) in Kuwait in 2001?
Keep it short and to the point. 2.14e+07. What is the difference between the Aid flow (current US$) of Georgia in 1998 and the Aid flow (current US$) of Peru in 2001?
Offer a terse response. -9.40e+05. What is the difference between the Aid flow (current US$) in Kuwait in 1998 and the Aid flow (current US$) in Peru in 2001?
Your answer should be compact. -2.34e+07. What is the difference between the Aid flow (current US$) in Small states in 1999 and the Aid flow (current US$) in Georgia in 2000?
Give a very brief answer. 5.68e+07. What is the difference between the Aid flow (current US$) of Small states in 1999 and the Aid flow (current US$) of Kuwait in 2000?
Ensure brevity in your answer.  7.54e+07. What is the difference between the Aid flow (current US$) in Small states in 1999 and the Aid flow (current US$) in Peru in 2000?
Keep it short and to the point. 4.20e+07. What is the difference between the Aid flow (current US$) of Georgia in 1999 and the Aid flow (current US$) of Kuwait in 2000?
Offer a terse response. 1.65e+07. What is the difference between the Aid flow (current US$) in Georgia in 1999 and the Aid flow (current US$) in Peru in 2000?
Offer a terse response. -1.69e+07. What is the difference between the Aid flow (current US$) in Kuwait in 1999 and the Aid flow (current US$) in Peru in 2000?
Make the answer very short. -3.32e+07. What is the difference between the Aid flow (current US$) in Small states in 1999 and the Aid flow (current US$) in Georgia in 2001?
Your answer should be very brief. 5.59e+07. What is the difference between the Aid flow (current US$) of Small states in 1999 and the Aid flow (current US$) of Kuwait in 2001?
Make the answer very short. 7.42e+07. What is the difference between the Aid flow (current US$) in Small states in 1999 and the Aid flow (current US$) in Peru in 2001?
Provide a short and direct response. 5.18e+07. What is the difference between the Aid flow (current US$) of Georgia in 1999 and the Aid flow (current US$) of Kuwait in 2001?
Make the answer very short. 1.53e+07. What is the difference between the Aid flow (current US$) in Georgia in 1999 and the Aid flow (current US$) in Peru in 2001?
Your answer should be very brief. -7.13e+06. What is the difference between the Aid flow (current US$) of Kuwait in 1999 and the Aid flow (current US$) of Peru in 2001?
Keep it short and to the point. -2.34e+07. What is the difference between the Aid flow (current US$) in Small states in 2000 and the Aid flow (current US$) in Georgia in 2001?
Offer a very short reply. 2.28e+07. What is the difference between the Aid flow (current US$) of Small states in 2000 and the Aid flow (current US$) of Kuwait in 2001?
Your response must be concise. 4.10e+07. What is the difference between the Aid flow (current US$) in Small states in 2000 and the Aid flow (current US$) in Peru in 2001?
Make the answer very short. 1.86e+07. What is the difference between the Aid flow (current US$) in Georgia in 2000 and the Aid flow (current US$) in Kuwait in 2001?
Offer a terse response. 1.74e+07. What is the difference between the Aid flow (current US$) of Georgia in 2000 and the Aid flow (current US$) of Peru in 2001?
Provide a short and direct response. -5.03e+06. What is the difference between the Aid flow (current US$) in Kuwait in 2000 and the Aid flow (current US$) in Peru in 2001?
Keep it short and to the point. -2.36e+07. What is the average Aid flow (current US$) in Small states per year?
Offer a very short reply. 6.37e+07. What is the average Aid flow (current US$) of Georgia per year?
Make the answer very short. 1.76e+07. What is the average Aid flow (current US$) of Kuwait per year?
Your answer should be compact. 5.54e+05. What is the average Aid flow (current US$) of Peru per year?
Your response must be concise. 4.31e+07. In the year 1994, what is the difference between the Aid flow (current US$) of Small states and Aid flow (current US$) of Georgia?
Ensure brevity in your answer.  8.32e+07. In the year 1994, what is the difference between the Aid flow (current US$) in Small states and Aid flow (current US$) in Kuwait?
Ensure brevity in your answer.  8.52e+07. In the year 1994, what is the difference between the Aid flow (current US$) in Small states and Aid flow (current US$) in Peru?
Keep it short and to the point. 3.36e+07. In the year 1994, what is the difference between the Aid flow (current US$) of Georgia and Aid flow (current US$) of Kuwait?
Your answer should be very brief. 2.04e+06. In the year 1994, what is the difference between the Aid flow (current US$) of Georgia and Aid flow (current US$) of Peru?
Your response must be concise. -4.96e+07. In the year 1994, what is the difference between the Aid flow (current US$) in Kuwait and Aid flow (current US$) in Peru?
Provide a succinct answer. -5.16e+07. In the year 1995, what is the difference between the Aid flow (current US$) in Small states and Aid flow (current US$) in Georgia?
Ensure brevity in your answer.  8.44e+07. In the year 1995, what is the difference between the Aid flow (current US$) of Small states and Aid flow (current US$) of Kuwait?
Your response must be concise. 9.45e+07. In the year 1995, what is the difference between the Aid flow (current US$) in Small states and Aid flow (current US$) in Peru?
Keep it short and to the point. 4.90e+07. In the year 1995, what is the difference between the Aid flow (current US$) of Georgia and Aid flow (current US$) of Kuwait?
Give a very brief answer. 1.00e+07. In the year 1995, what is the difference between the Aid flow (current US$) in Georgia and Aid flow (current US$) in Peru?
Provide a short and direct response. -3.54e+07. In the year 1995, what is the difference between the Aid flow (current US$) of Kuwait and Aid flow (current US$) of Peru?
Keep it short and to the point. -4.54e+07. In the year 1996, what is the difference between the Aid flow (current US$) of Small states and Aid flow (current US$) of Georgia?
Provide a short and direct response. 3.22e+07. In the year 1996, what is the difference between the Aid flow (current US$) of Small states and Aid flow (current US$) of Kuwait?
Offer a very short reply. 6.57e+07. In the year 1996, what is the difference between the Aid flow (current US$) in Small states and Aid flow (current US$) in Peru?
Offer a terse response. 2.34e+07. In the year 1996, what is the difference between the Aid flow (current US$) in Georgia and Aid flow (current US$) in Kuwait?
Provide a short and direct response. 3.35e+07. In the year 1996, what is the difference between the Aid flow (current US$) in Georgia and Aid flow (current US$) in Peru?
Offer a very short reply. -8.77e+06. In the year 1996, what is the difference between the Aid flow (current US$) in Kuwait and Aid flow (current US$) in Peru?
Provide a short and direct response. -4.22e+07. In the year 1997, what is the difference between the Aid flow (current US$) of Small states and Aid flow (current US$) of Georgia?
Offer a terse response. 3.08e+07. In the year 1997, what is the difference between the Aid flow (current US$) in Small states and Aid flow (current US$) in Kuwait?
Your answer should be very brief. 4.61e+07. In the year 1997, what is the difference between the Aid flow (current US$) in Small states and Aid flow (current US$) in Peru?
Your answer should be very brief. -3.89e+07. In the year 1997, what is the difference between the Aid flow (current US$) of Georgia and Aid flow (current US$) of Kuwait?
Give a very brief answer. 1.53e+07. In the year 1997, what is the difference between the Aid flow (current US$) of Georgia and Aid flow (current US$) of Peru?
Give a very brief answer. -6.96e+07. In the year 1997, what is the difference between the Aid flow (current US$) in Kuwait and Aid flow (current US$) in Peru?
Provide a succinct answer. -8.50e+07. In the year 1998, what is the difference between the Aid flow (current US$) in Small states and Aid flow (current US$) in Georgia?
Offer a very short reply. 4.43e+07. In the year 1998, what is the difference between the Aid flow (current US$) in Small states and Aid flow (current US$) in Kuwait?
Provide a short and direct response. 6.68e+07. In the year 1998, what is the difference between the Aid flow (current US$) of Small states and Aid flow (current US$) of Peru?
Your answer should be very brief. 1.72e+07. In the year 1998, what is the difference between the Aid flow (current US$) in Georgia and Aid flow (current US$) in Kuwait?
Make the answer very short. 2.24e+07. In the year 1998, what is the difference between the Aid flow (current US$) of Georgia and Aid flow (current US$) of Peru?
Your answer should be very brief. -2.71e+07. In the year 1998, what is the difference between the Aid flow (current US$) in Kuwait and Aid flow (current US$) in Peru?
Provide a succinct answer. -4.96e+07. In the year 1999, what is the difference between the Aid flow (current US$) in Small states and Aid flow (current US$) in Georgia?
Your response must be concise. 5.90e+07. In the year 1999, what is the difference between the Aid flow (current US$) in Small states and Aid flow (current US$) in Kuwait?
Ensure brevity in your answer.  7.52e+07. In the year 1999, what is the difference between the Aid flow (current US$) in Small states and Aid flow (current US$) in Peru?
Ensure brevity in your answer.  6.47e+07. In the year 1999, what is the difference between the Aid flow (current US$) in Georgia and Aid flow (current US$) in Kuwait?
Offer a terse response. 1.63e+07. In the year 1999, what is the difference between the Aid flow (current US$) of Georgia and Aid flow (current US$) of Peru?
Your answer should be very brief. 5.74e+06. In the year 1999, what is the difference between the Aid flow (current US$) in Kuwait and Aid flow (current US$) in Peru?
Offer a very short reply. -1.05e+07. In the year 2000, what is the difference between the Aid flow (current US$) of Small states and Aid flow (current US$) of Georgia?
Your response must be concise. 2.37e+07. In the year 2000, what is the difference between the Aid flow (current US$) in Small states and Aid flow (current US$) in Kuwait?
Your answer should be very brief. 4.22e+07. In the year 2000, what is the difference between the Aid flow (current US$) of Small states and Aid flow (current US$) of Peru?
Ensure brevity in your answer.  8.84e+06. In the year 2000, what is the difference between the Aid flow (current US$) of Georgia and Aid flow (current US$) of Kuwait?
Provide a short and direct response. 1.86e+07. In the year 2000, what is the difference between the Aid flow (current US$) in Georgia and Aid flow (current US$) in Peru?
Make the answer very short. -1.48e+07. In the year 2000, what is the difference between the Aid flow (current US$) of Kuwait and Aid flow (current US$) of Peru?
Offer a terse response. -3.34e+07. In the year 2001, what is the difference between the Aid flow (current US$) in Small states and Aid flow (current US$) in Georgia?
Make the answer very short. 1.12e+07. In the year 2001, what is the difference between the Aid flow (current US$) in Small states and Aid flow (current US$) in Kuwait?
Ensure brevity in your answer.  2.95e+07. In the year 2001, what is the difference between the Aid flow (current US$) of Small states and Aid flow (current US$) of Peru?
Your answer should be very brief. 7.14e+06. In the year 2001, what is the difference between the Aid flow (current US$) of Georgia and Aid flow (current US$) of Kuwait?
Provide a short and direct response. 1.83e+07. In the year 2001, what is the difference between the Aid flow (current US$) in Georgia and Aid flow (current US$) in Peru?
Provide a short and direct response. -4.11e+06. In the year 2001, what is the difference between the Aid flow (current US$) of Kuwait and Aid flow (current US$) of Peru?
Keep it short and to the point. -2.24e+07. What is the ratio of the Aid flow (current US$) of Small states in 1994 to that in 1995?
Your answer should be very brief. 0.9. What is the ratio of the Aid flow (current US$) of Georgia in 1994 to that in 1995?
Give a very brief answer. 0.21. What is the ratio of the Aid flow (current US$) in Kuwait in 1994 to that in 1995?
Provide a succinct answer. 0.53. What is the ratio of the Aid flow (current US$) in Peru in 1994 to that in 1995?
Make the answer very short. 1.13. What is the ratio of the Aid flow (current US$) of Small states in 1994 to that in 1996?
Offer a very short reply. 1.3. What is the ratio of the Aid flow (current US$) of Georgia in 1994 to that in 1996?
Provide a succinct answer. 0.06. What is the ratio of the Aid flow (current US$) in Peru in 1994 to that in 1996?
Offer a very short reply. 1.22. What is the ratio of the Aid flow (current US$) in Small states in 1994 to that in 1997?
Provide a succinct answer. 1.85. What is the ratio of the Aid flow (current US$) of Georgia in 1994 to that in 1997?
Provide a succinct answer. 0.14. What is the ratio of the Aid flow (current US$) in Kuwait in 1994 to that in 1997?
Offer a terse response. 0.67. What is the ratio of the Aid flow (current US$) in Peru in 1994 to that in 1997?
Give a very brief answer. 0.61. What is the ratio of the Aid flow (current US$) of Small states in 1994 to that in 1998?
Your answer should be compact. 1.26. What is the ratio of the Aid flow (current US$) in Georgia in 1994 to that in 1998?
Offer a very short reply. 0.09. What is the ratio of the Aid flow (current US$) of Peru in 1994 to that in 1998?
Offer a very short reply. 1.03. What is the ratio of the Aid flow (current US$) in Small states in 1994 to that in 1999?
Your answer should be compact. 1.12. What is the ratio of the Aid flow (current US$) of Georgia in 1994 to that in 1999?
Provide a short and direct response. 0.12. What is the ratio of the Aid flow (current US$) of Kuwait in 1994 to that in 1999?
Your answer should be compact. 0.1. What is the ratio of the Aid flow (current US$) in Peru in 1994 to that in 1999?
Provide a succinct answer. 4.57. What is the ratio of the Aid flow (current US$) in Small states in 1994 to that in 2000?
Keep it short and to the point. 1.99. What is the ratio of the Aid flow (current US$) in Georgia in 1994 to that in 2000?
Give a very brief answer. 0.11. What is the ratio of the Aid flow (current US$) of Kuwait in 1994 to that in 2000?
Give a very brief answer. 0.14. What is the ratio of the Aid flow (current US$) of Peru in 1994 to that in 2000?
Offer a very short reply. 1.52. What is the ratio of the Aid flow (current US$) in Small states in 1994 to that in 2001?
Keep it short and to the point. 2.72. What is the ratio of the Aid flow (current US$) in Georgia in 1994 to that in 2001?
Provide a short and direct response. 0.11. What is the ratio of the Aid flow (current US$) in Kuwait in 1994 to that in 2001?
Give a very brief answer. 0.04. What is the ratio of the Aid flow (current US$) of Peru in 1994 to that in 2001?
Make the answer very short. 2.14. What is the ratio of the Aid flow (current US$) in Small states in 1995 to that in 1996?
Your answer should be very brief. 1.44. What is the ratio of the Aid flow (current US$) in Georgia in 1995 to that in 1996?
Provide a short and direct response. 0.3. What is the ratio of the Aid flow (current US$) of Kuwait in 1995 to that in 1996?
Make the answer very short. 1.07. What is the ratio of the Aid flow (current US$) in Peru in 1995 to that in 1996?
Offer a very short reply. 1.08. What is the ratio of the Aid flow (current US$) of Small states in 1995 to that in 1997?
Provide a short and direct response. 2.05. What is the ratio of the Aid flow (current US$) of Georgia in 1995 to that in 1997?
Your response must be concise. 0.66. What is the ratio of the Aid flow (current US$) in Kuwait in 1995 to that in 1997?
Your response must be concise. 1.25. What is the ratio of the Aid flow (current US$) of Peru in 1995 to that in 1997?
Ensure brevity in your answer.  0.54. What is the ratio of the Aid flow (current US$) of Small states in 1995 to that in 1998?
Your answer should be very brief. 1.4. What is the ratio of the Aid flow (current US$) in Georgia in 1995 to that in 1998?
Your answer should be very brief. 0.44. What is the ratio of the Aid flow (current US$) in Kuwait in 1995 to that in 1998?
Provide a succinct answer. 0.19. What is the ratio of the Aid flow (current US$) of Peru in 1995 to that in 1998?
Make the answer very short. 0.91. What is the ratio of the Aid flow (current US$) of Small states in 1995 to that in 1999?
Give a very brief answer. 1.25. What is the ratio of the Aid flow (current US$) of Georgia in 1995 to that in 1999?
Ensure brevity in your answer.  0.6. What is the ratio of the Aid flow (current US$) in Kuwait in 1995 to that in 1999?
Your response must be concise. 0.19. What is the ratio of the Aid flow (current US$) of Peru in 1995 to that in 1999?
Your response must be concise. 4.03. What is the ratio of the Aid flow (current US$) of Small states in 1995 to that in 2000?
Provide a short and direct response. 2.21. What is the ratio of the Aid flow (current US$) in Georgia in 1995 to that in 2000?
Offer a terse response. 0.53. What is the ratio of the Aid flow (current US$) in Kuwait in 1995 to that in 2000?
Your response must be concise. 0.26. What is the ratio of the Aid flow (current US$) in Peru in 1995 to that in 2000?
Keep it short and to the point. 1.34. What is the ratio of the Aid flow (current US$) in Small states in 1995 to that in 2001?
Make the answer very short. 3.02. What is the ratio of the Aid flow (current US$) of Georgia in 1995 to that in 2001?
Provide a short and direct response. 0.51. What is the ratio of the Aid flow (current US$) of Kuwait in 1995 to that in 2001?
Make the answer very short. 0.08. What is the ratio of the Aid flow (current US$) in Peru in 1995 to that in 2001?
Keep it short and to the point. 1.89. What is the ratio of the Aid flow (current US$) in Small states in 1996 to that in 1997?
Your answer should be very brief. 1.42. What is the ratio of the Aid flow (current US$) in Georgia in 1996 to that in 1997?
Give a very brief answer. 2.18. What is the ratio of the Aid flow (current US$) in Peru in 1996 to that in 1997?
Offer a terse response. 0.5. What is the ratio of the Aid flow (current US$) of Small states in 1996 to that in 1998?
Provide a short and direct response. 0.97. What is the ratio of the Aid flow (current US$) of Georgia in 1996 to that in 1998?
Offer a very short reply. 1.45. What is the ratio of the Aid flow (current US$) in Kuwait in 1996 to that in 1998?
Provide a short and direct response. 0.17. What is the ratio of the Aid flow (current US$) of Peru in 1996 to that in 1998?
Give a very brief answer. 0.84. What is the ratio of the Aid flow (current US$) of Small states in 1996 to that in 1999?
Provide a succinct answer. 0.87. What is the ratio of the Aid flow (current US$) in Georgia in 1996 to that in 1999?
Your answer should be compact. 1.97. What is the ratio of the Aid flow (current US$) of Kuwait in 1996 to that in 1999?
Ensure brevity in your answer.  0.18. What is the ratio of the Aid flow (current US$) of Peru in 1996 to that in 1999?
Offer a terse response. 3.75. What is the ratio of the Aid flow (current US$) in Small states in 1996 to that in 2000?
Offer a very short reply. 1.54. What is the ratio of the Aid flow (current US$) of Georgia in 1996 to that in 2000?
Your answer should be very brief. 1.76. What is the ratio of the Aid flow (current US$) of Kuwait in 1996 to that in 2000?
Give a very brief answer. 0.24. What is the ratio of the Aid flow (current US$) of Peru in 1996 to that in 2000?
Keep it short and to the point. 1.25. What is the ratio of the Aid flow (current US$) of Small states in 1996 to that in 2001?
Offer a terse response. 2.1. What is the ratio of the Aid flow (current US$) in Georgia in 1996 to that in 2001?
Offer a very short reply. 1.68. What is the ratio of the Aid flow (current US$) in Kuwait in 1996 to that in 2001?
Ensure brevity in your answer.  0.08. What is the ratio of the Aid flow (current US$) of Peru in 1996 to that in 2001?
Offer a terse response. 1.75. What is the ratio of the Aid flow (current US$) in Small states in 1997 to that in 1998?
Offer a terse response. 0.68. What is the ratio of the Aid flow (current US$) in Georgia in 1997 to that in 1998?
Offer a terse response. 0.66. What is the ratio of the Aid flow (current US$) in Kuwait in 1997 to that in 1998?
Your answer should be very brief. 0.15. What is the ratio of the Aid flow (current US$) of Peru in 1997 to that in 1998?
Your answer should be compact. 1.69. What is the ratio of the Aid flow (current US$) in Small states in 1997 to that in 1999?
Your response must be concise. 0.61. What is the ratio of the Aid flow (current US$) in Georgia in 1997 to that in 1999?
Your answer should be compact. 0.91. What is the ratio of the Aid flow (current US$) in Kuwait in 1997 to that in 1999?
Keep it short and to the point. 0.15. What is the ratio of the Aid flow (current US$) of Peru in 1997 to that in 1999?
Keep it short and to the point. 7.53. What is the ratio of the Aid flow (current US$) of Small states in 1997 to that in 2000?
Provide a short and direct response. 1.08. What is the ratio of the Aid flow (current US$) in Georgia in 1997 to that in 2000?
Provide a succinct answer. 0.81. What is the ratio of the Aid flow (current US$) of Kuwait in 1997 to that in 2000?
Give a very brief answer. 0.21. What is the ratio of the Aid flow (current US$) of Peru in 1997 to that in 2000?
Offer a very short reply. 2.5. What is the ratio of the Aid flow (current US$) of Small states in 1997 to that in 2001?
Make the answer very short. 1.48. What is the ratio of the Aid flow (current US$) in Georgia in 1997 to that in 2001?
Provide a short and direct response. 0.77. What is the ratio of the Aid flow (current US$) of Kuwait in 1997 to that in 2001?
Provide a short and direct response. 0.07. What is the ratio of the Aid flow (current US$) in Peru in 1997 to that in 2001?
Provide a short and direct response. 3.52. What is the ratio of the Aid flow (current US$) of Small states in 1998 to that in 1999?
Keep it short and to the point. 0.89. What is the ratio of the Aid flow (current US$) in Georgia in 1998 to that in 1999?
Offer a terse response. 1.36. What is the ratio of the Aid flow (current US$) of Kuwait in 1998 to that in 1999?
Provide a succinct answer. 1.03. What is the ratio of the Aid flow (current US$) of Peru in 1998 to that in 1999?
Offer a very short reply. 4.46. What is the ratio of the Aid flow (current US$) in Small states in 1998 to that in 2000?
Make the answer very short. 1.58. What is the ratio of the Aid flow (current US$) in Georgia in 1998 to that in 2000?
Keep it short and to the point. 1.21. What is the ratio of the Aid flow (current US$) of Kuwait in 1998 to that in 2000?
Give a very brief answer. 1.38. What is the ratio of the Aid flow (current US$) of Peru in 1998 to that in 2000?
Keep it short and to the point. 1.48. What is the ratio of the Aid flow (current US$) of Small states in 1998 to that in 2001?
Your answer should be very brief. 2.16. What is the ratio of the Aid flow (current US$) in Georgia in 1998 to that in 2001?
Offer a terse response. 1.16. What is the ratio of the Aid flow (current US$) of Kuwait in 1998 to that in 2001?
Your answer should be compact. 0.45. What is the ratio of the Aid flow (current US$) in Peru in 1998 to that in 2001?
Offer a very short reply. 2.08. What is the ratio of the Aid flow (current US$) in Small states in 1999 to that in 2000?
Make the answer very short. 1.78. What is the ratio of the Aid flow (current US$) in Georgia in 1999 to that in 2000?
Your answer should be very brief. 0.89. What is the ratio of the Aid flow (current US$) of Kuwait in 1999 to that in 2000?
Offer a terse response. 1.34. What is the ratio of the Aid flow (current US$) in Peru in 1999 to that in 2000?
Keep it short and to the point. 0.33. What is the ratio of the Aid flow (current US$) in Small states in 1999 to that in 2001?
Your answer should be very brief. 2.43. What is the ratio of the Aid flow (current US$) in Georgia in 1999 to that in 2001?
Your answer should be very brief. 0.85. What is the ratio of the Aid flow (current US$) in Kuwait in 1999 to that in 2001?
Provide a short and direct response. 0.44. What is the ratio of the Aid flow (current US$) of Peru in 1999 to that in 2001?
Provide a short and direct response. 0.47. What is the ratio of the Aid flow (current US$) in Small states in 2000 to that in 2001?
Give a very brief answer. 1.37. What is the ratio of the Aid flow (current US$) in Georgia in 2000 to that in 2001?
Keep it short and to the point. 0.95. What is the ratio of the Aid flow (current US$) in Kuwait in 2000 to that in 2001?
Ensure brevity in your answer.  0.33. What is the ratio of the Aid flow (current US$) in Peru in 2000 to that in 2001?
Ensure brevity in your answer.  1.41. What is the difference between the highest and the second highest Aid flow (current US$) in Small states?
Give a very brief answer. 9.32e+06. What is the difference between the highest and the second highest Aid flow (current US$) in Georgia?
Your answer should be very brief. 1.04e+07. What is the difference between the highest and the second highest Aid flow (current US$) in Kuwait?
Provide a succinct answer. 9.80e+05. What is the difference between the highest and the second highest Aid flow (current US$) of Peru?
Offer a very short reply. 3.34e+07. What is the difference between the highest and the lowest Aid flow (current US$) of Small states?
Keep it short and to the point. 6.33e+07. What is the difference between the highest and the lowest Aid flow (current US$) of Georgia?
Make the answer very short. 3.15e+07. What is the difference between the highest and the lowest Aid flow (current US$) of Kuwait?
Make the answer very short. 1.70e+06. What is the difference between the highest and the lowest Aid flow (current US$) of Peru?
Provide a short and direct response. 7.38e+07. 